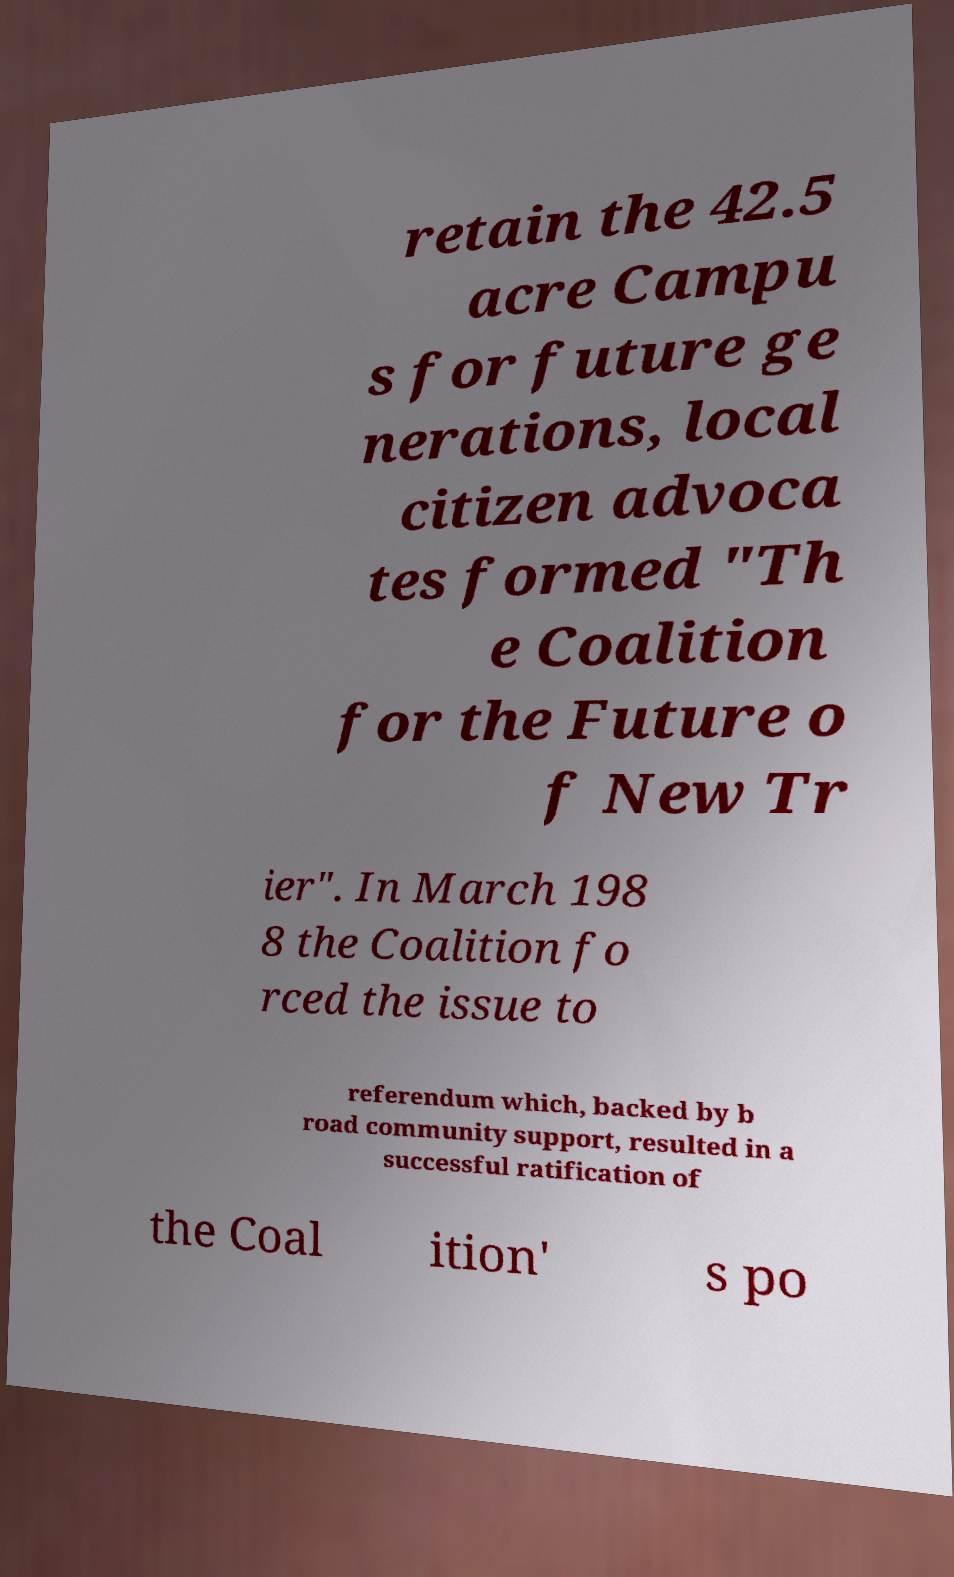Please identify and transcribe the text found in this image. retain the 42.5 acre Campu s for future ge nerations, local citizen advoca tes formed "Th e Coalition for the Future o f New Tr ier". In March 198 8 the Coalition fo rced the issue to referendum which, backed by b road community support, resulted in a successful ratification of the Coal ition' s po 